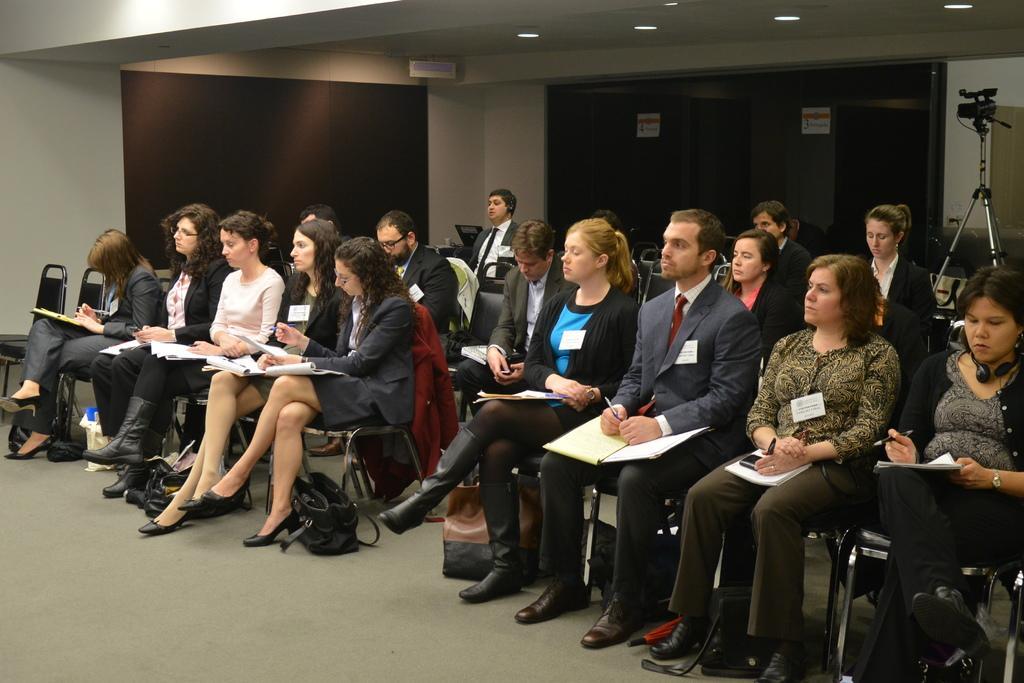Could you give a brief overview of what you see in this image? In this image we can see people sitting there are books, pens, bags and a mobile. On the right there is a camera placed on the stand. At the top there are lights and we can see boards. 